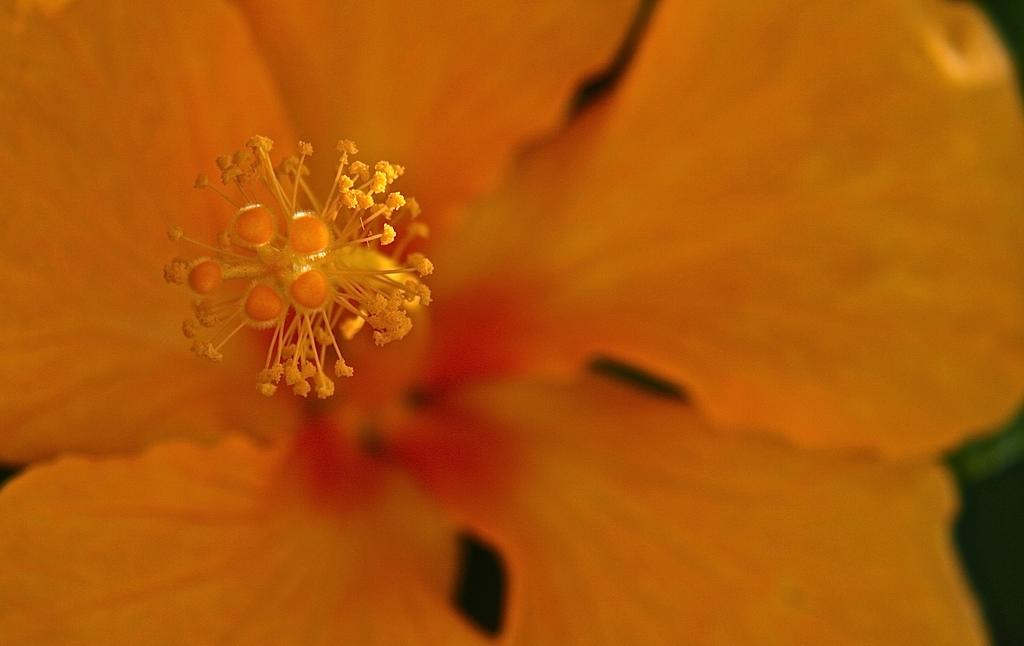What is the main subject of the image? There is a flower in the image. How many plates are stacked next to the flower in the image? There is no plate present in the image; it only features a flower. What type of spiders can be seen crawling on the petals of the flower in the image? There are no spiders present in the image; it only features a flower. 